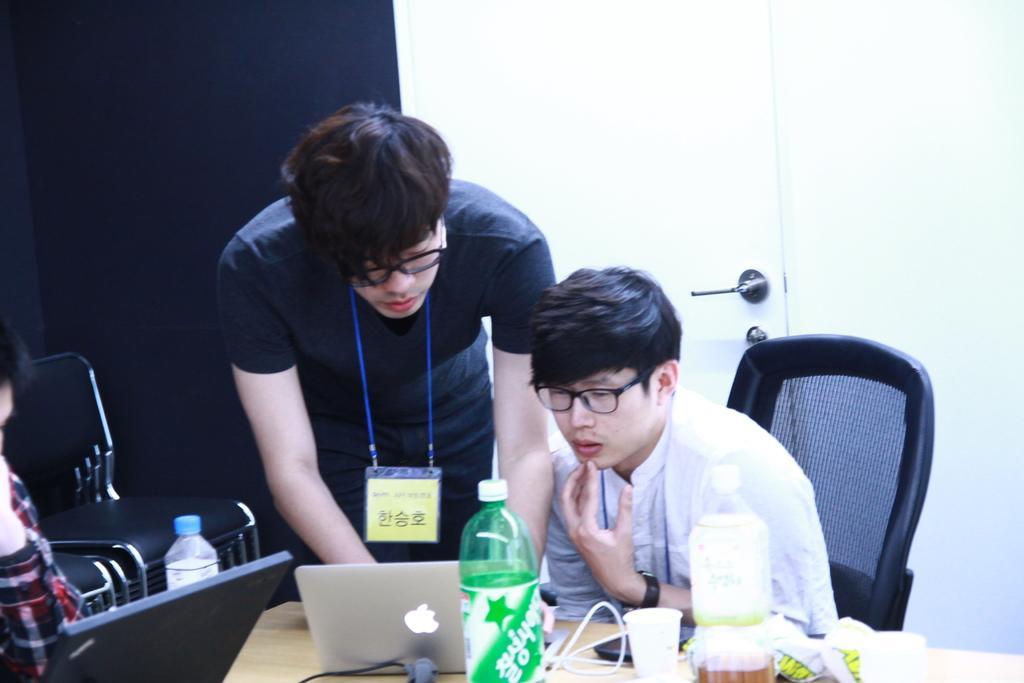Can you describe this image briefly? In the image I can see a person who is sitting on the chair and the other guy who is wearing the tag and standing in front of the table on which there is a laptop and some other things and also I can see the other person to the side. 